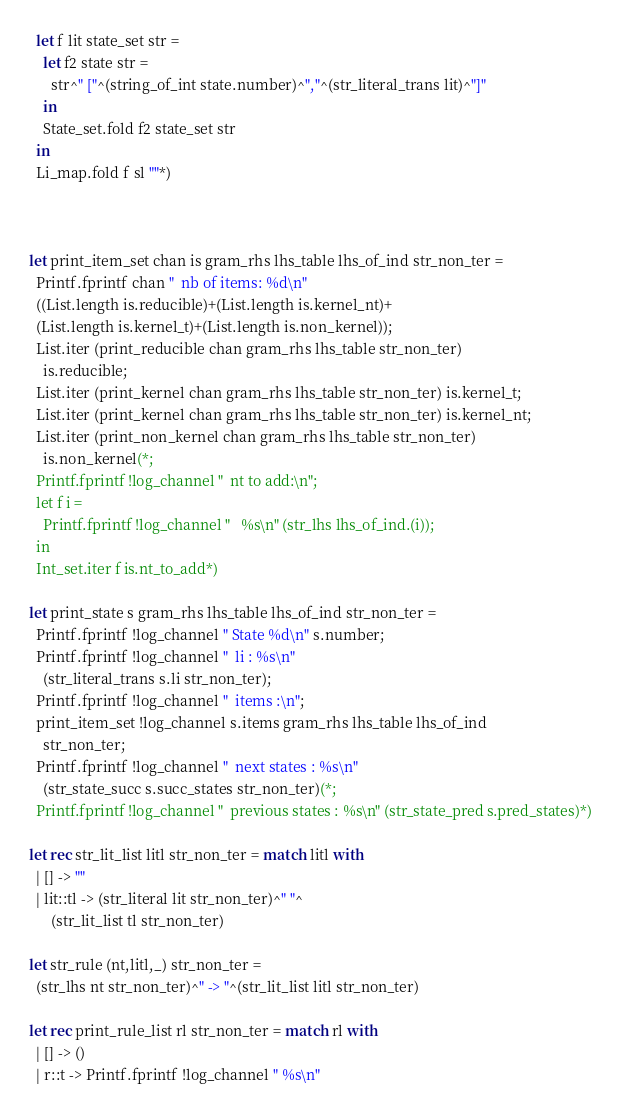Convert code to text. <code><loc_0><loc_0><loc_500><loc_500><_OCaml_>  let f lit state_set str =
    let f2 state str =
      str^" ["^(string_of_int state.number)^","^(str_literal_trans lit)^"]"
    in
    State_set.fold f2 state_set str
  in
  Li_map.fold f sl ""*)



let print_item_set chan is gram_rhs lhs_table lhs_of_ind str_non_ter =
  Printf.fprintf chan "  nb of items: %d\n"
  ((List.length is.reducible)+(List.length is.kernel_nt)+
  (List.length is.kernel_t)+(List.length is.non_kernel));
  List.iter (print_reducible chan gram_rhs lhs_table str_non_ter)
    is.reducible;
  List.iter (print_kernel chan gram_rhs lhs_table str_non_ter) is.kernel_t;
  List.iter (print_kernel chan gram_rhs lhs_table str_non_ter) is.kernel_nt;
  List.iter (print_non_kernel chan gram_rhs lhs_table str_non_ter)
    is.non_kernel(*;
  Printf.fprintf !log_channel "  nt to add:\n";
  let f i =
    Printf.fprintf !log_channel "   %s\n" (str_lhs lhs_of_ind.(i));
  in
  Int_set.iter f is.nt_to_add*)

let print_state s gram_rhs lhs_table lhs_of_ind str_non_ter =
  Printf.fprintf !log_channel " State %d\n" s.number;
  Printf.fprintf !log_channel "  li : %s\n"
    (str_literal_trans s.li str_non_ter);
  Printf.fprintf !log_channel "  items :\n";
  print_item_set !log_channel s.items gram_rhs lhs_table lhs_of_ind
    str_non_ter;
  Printf.fprintf !log_channel "  next states : %s\n"
    (str_state_succ s.succ_states str_non_ter)(*;
  Printf.fprintf !log_channel "  previous states : %s\n" (str_state_pred s.pred_states)*)

let rec str_lit_list litl str_non_ter = match litl with
  | [] -> ""
  | lit::tl -> (str_literal lit str_non_ter)^" "^
      (str_lit_list tl str_non_ter)

let str_rule (nt,litl,_) str_non_ter =
  (str_lhs nt str_non_ter)^" -> "^(str_lit_list litl str_non_ter)

let rec print_rule_list rl str_non_ter = match rl with
  | [] -> ()
  | r::t -> Printf.fprintf !log_channel " %s\n"</code> 